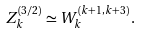Convert formula to latex. <formula><loc_0><loc_0><loc_500><loc_500>Z _ { k } ^ { ( 3 / 2 ) } \simeq W _ { k } ^ { ( k + 1 , k + 3 ) } \, .</formula> 